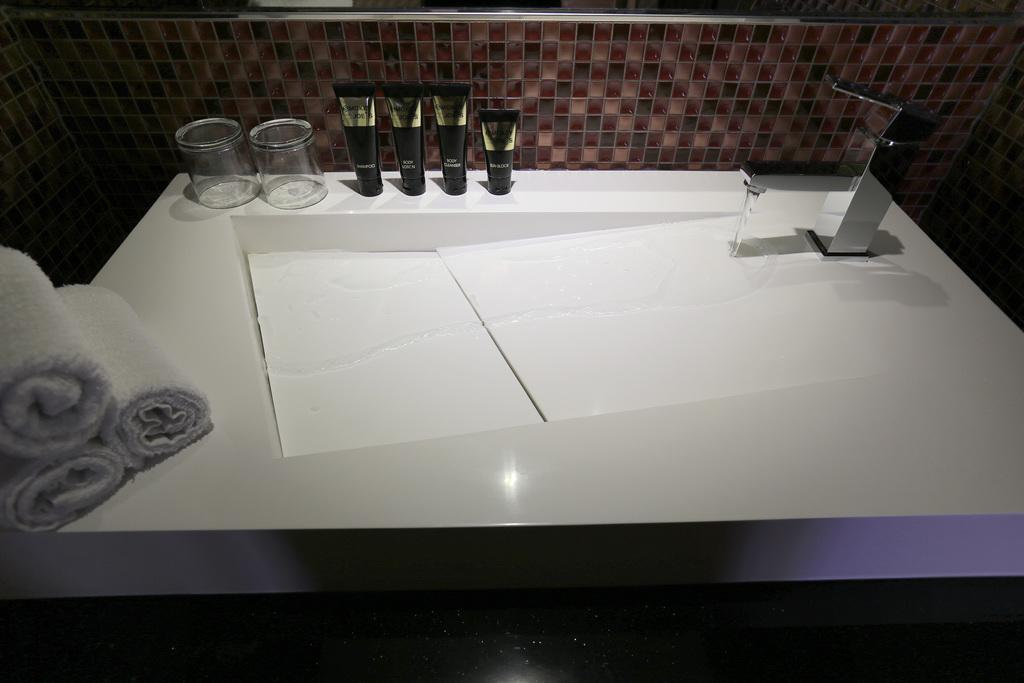What is the main object in the image? There is a tap in the image. What is the tap connected to? The tap is connected to a sink in the image. What can be seen in the sink? There is water visible in the sink. What objects are on the white surface? There are glasses, tubes, and towels on the white surface. What is visible in the background of the image? There is a wall visible in the background. What type of scarf is the writer wearing in the image? There is no writer or scarf present in the image. How does the paste help in cleaning the glasses in the image? There is no paste mentioned or visible in the image. 